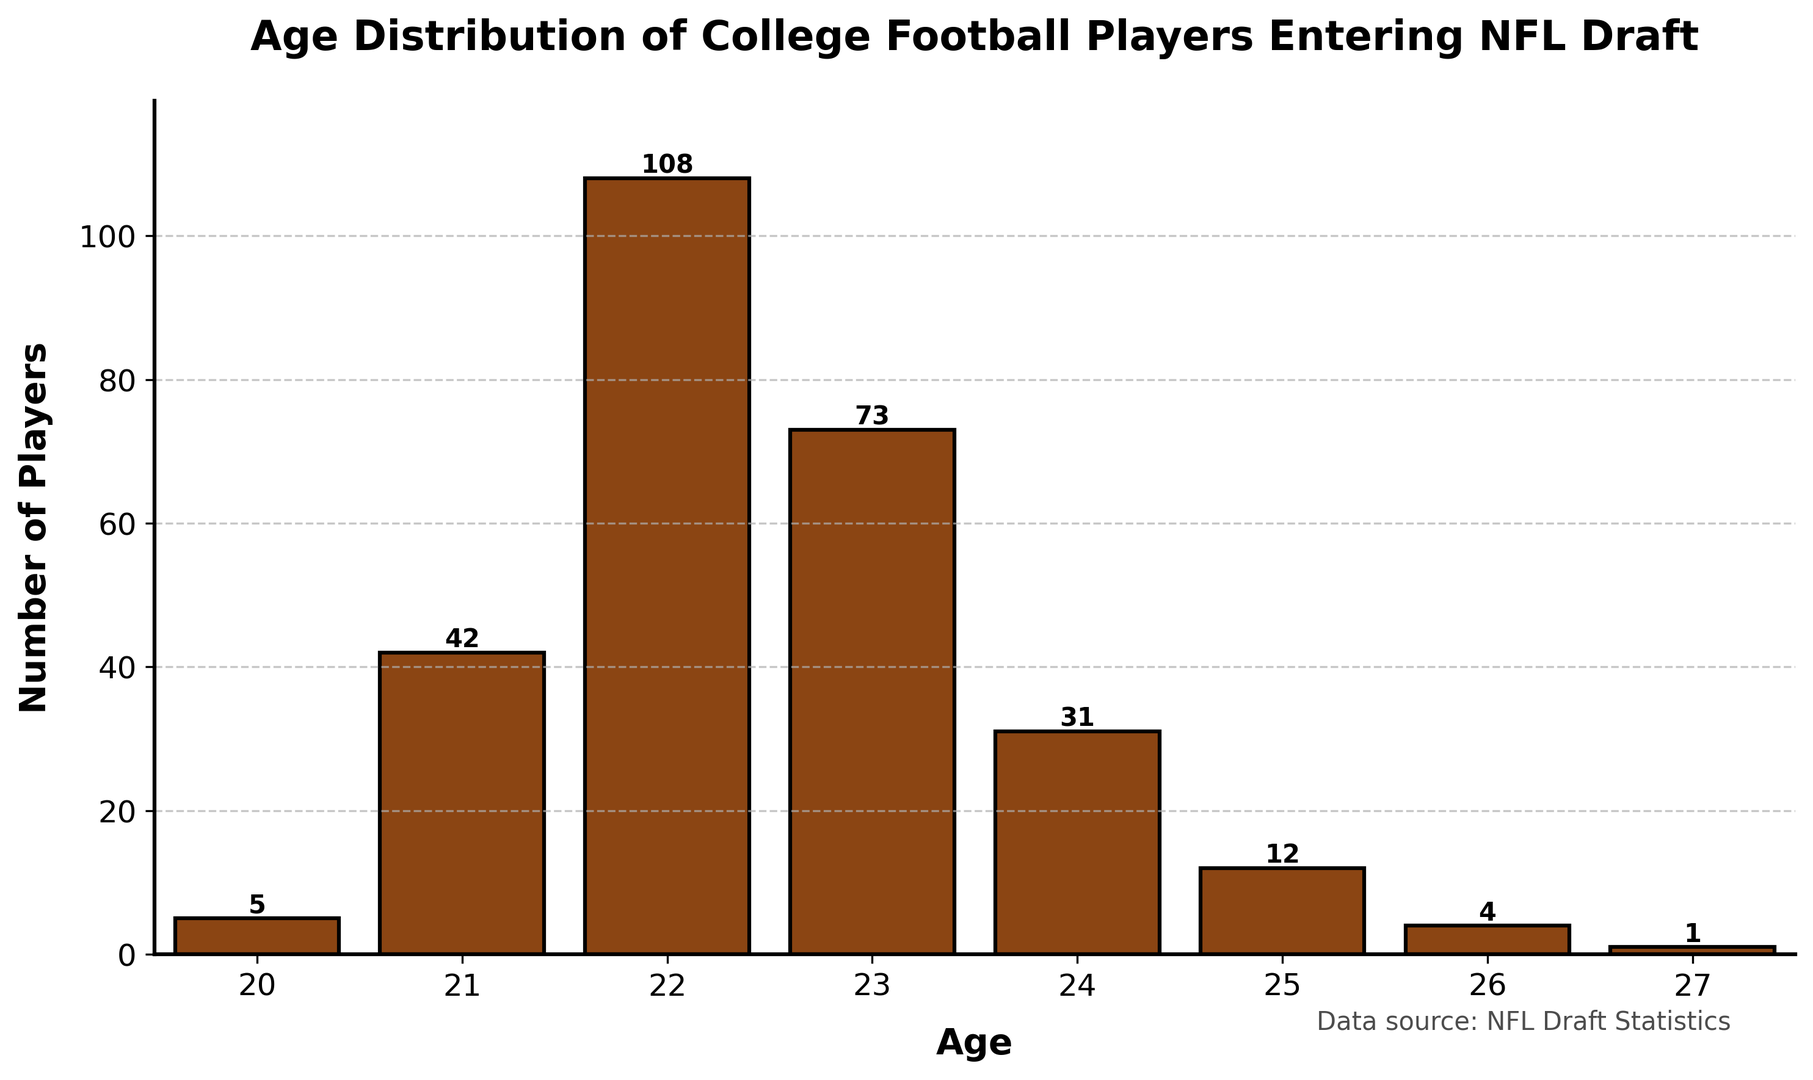What's the most common age of college football players entering the NFL draft? The height of the bars represents the number of players. The tallest bar corresponds to age 22.
Answer: 22 How many more players are 22 years old compared to 24 years old? Subtract the count of 24-year-old players from the count of 22-year-old players: 108 - 31 = 77.
Answer: 77 Which age has the least number of players entering the draft? The shortest bar is for age 27, representing the least number of players.
Answer: 27 What is the total number of players aged between 21 and 23? Add the counts of players who are 21, 22, and 23 years old: 42 + 108 + 73 = 223.
Answer: 223 Do more players enter the draft at ages 20 and 21 combined, or at age 23 alone? Compare the sum of counts for ages 20 and 21: 5 + 42 = 47, with the count for age 23: 73. 73 is greater than 47.
Answer: Age 23 alone By how much does the number of 25-year-old players exceed the number of 26-year-old players? Subtract the count of 26-year-old players from the count of 25-year-old players: 12 - 4 = 8.
Answer: 8 What percentage of the total number of players are 21 years old? First, find the total number of players: 5 + 42 + 108 + 73 + 31 + 12 + 4 + 1 = 276. Then calculate the percentage: (42 / 276) * 100 ≈ 15.22%.
Answer: ~15.22% Which age group has a count closest to 30 players? Age 24 has 31 players, which is closest to 30.
Answer: 24 Is the number of players older than 24 equal to the number of players younger than 21? Sum the counts for ages older than 24: 12 (25) + 4 (26) + 1 (27) = 17. Sum the counts for ages younger than 21: 5 (20). 17 is not equal to 5.
Answer: No How many ages have more than 40 players entering the draft? Identify the counts greater than 40: 42 (21), 108 (22), and 73 (23). There are 3 ages.
Answer: 3 